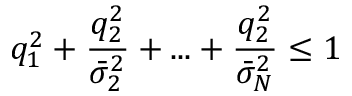Convert formula to latex. <formula><loc_0><loc_0><loc_500><loc_500>q _ { 1 } ^ { 2 } + \frac { q _ { 2 } ^ { 2 } } { \bar { \sigma } _ { 2 } ^ { 2 } } + \dots + \frac { q _ { 2 } ^ { 2 } } { \bar { \sigma } _ { N } ^ { 2 } } \leq 1</formula> 